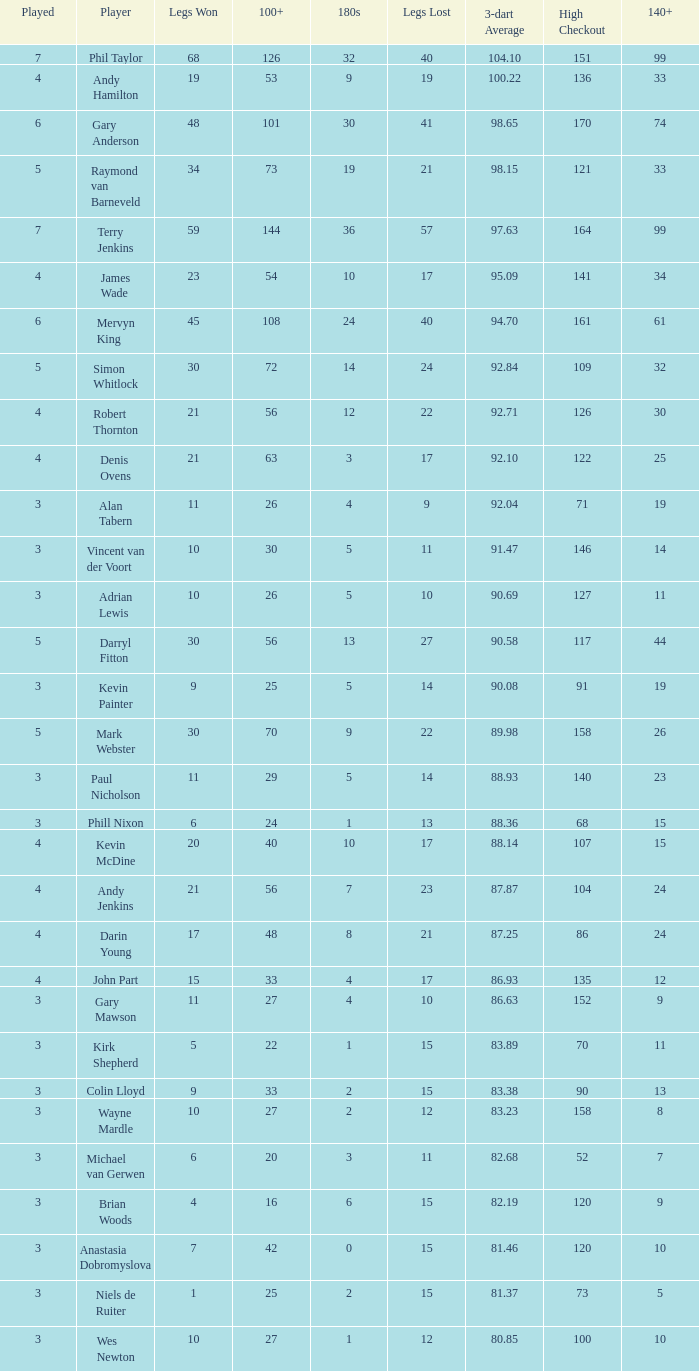What is the most legs lost of all? 57.0. 